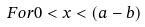<formula> <loc_0><loc_0><loc_500><loc_500>F o r 0 < x < ( a - b )</formula> 